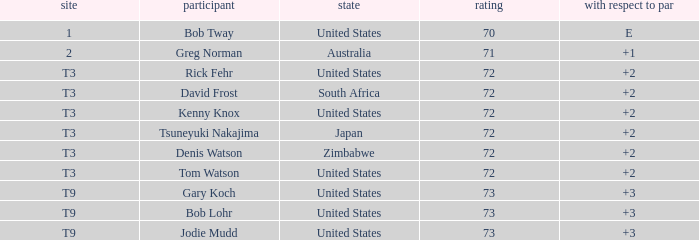Who scored more than 72? Gary Koch, Bob Lohr, Jodie Mudd. 